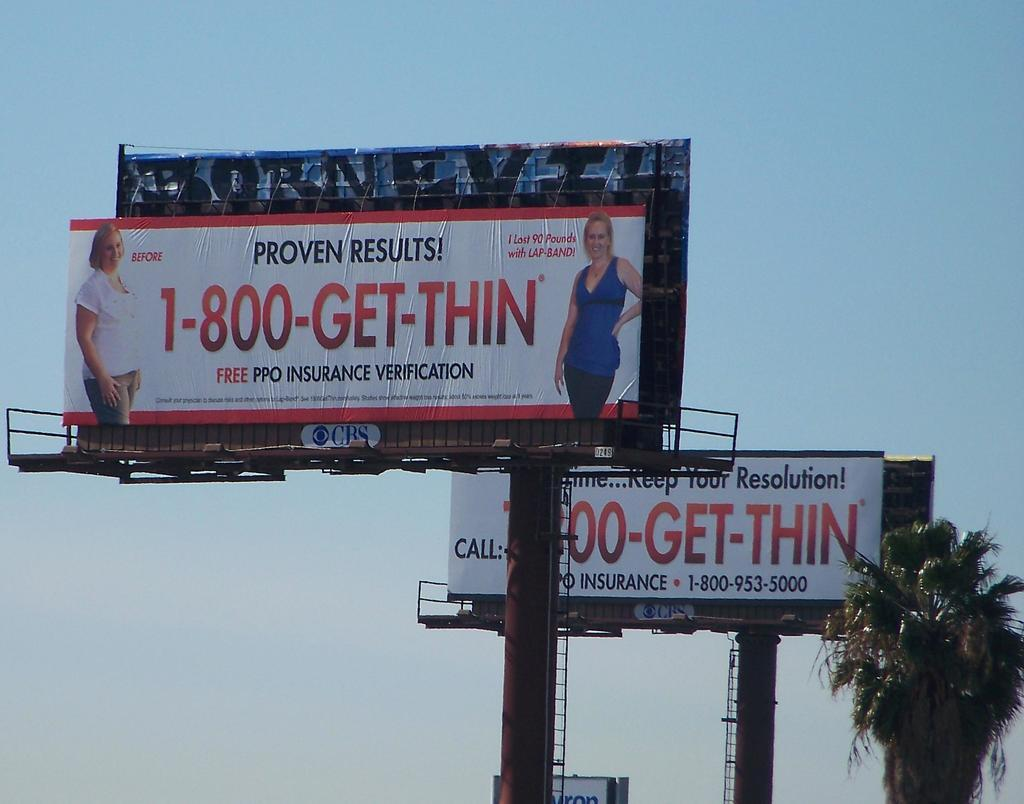Provide a one-sentence caption for the provided image. Two billboards advertising a solution to get thin fast stand beside a palm tree. 